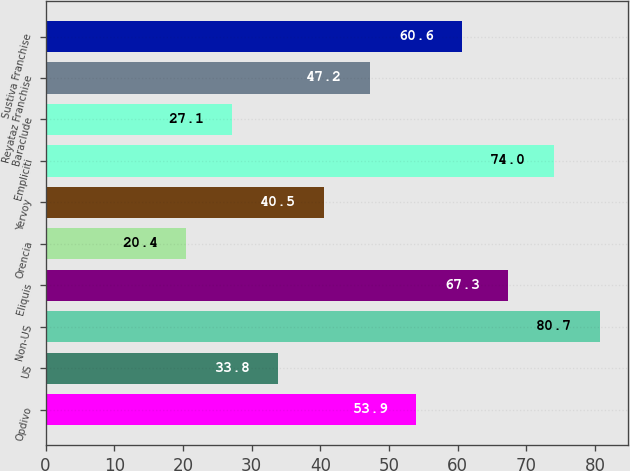Convert chart to OTSL. <chart><loc_0><loc_0><loc_500><loc_500><bar_chart><fcel>Opdivo<fcel>US<fcel>Non-US<fcel>Eliquis<fcel>Orencia<fcel>Yervoy<fcel>Empliciti<fcel>Baraclude<fcel>Reyataz Franchise<fcel>Sustiva Franchise<nl><fcel>53.9<fcel>33.8<fcel>80.7<fcel>67.3<fcel>20.4<fcel>40.5<fcel>74<fcel>27.1<fcel>47.2<fcel>60.6<nl></chart> 